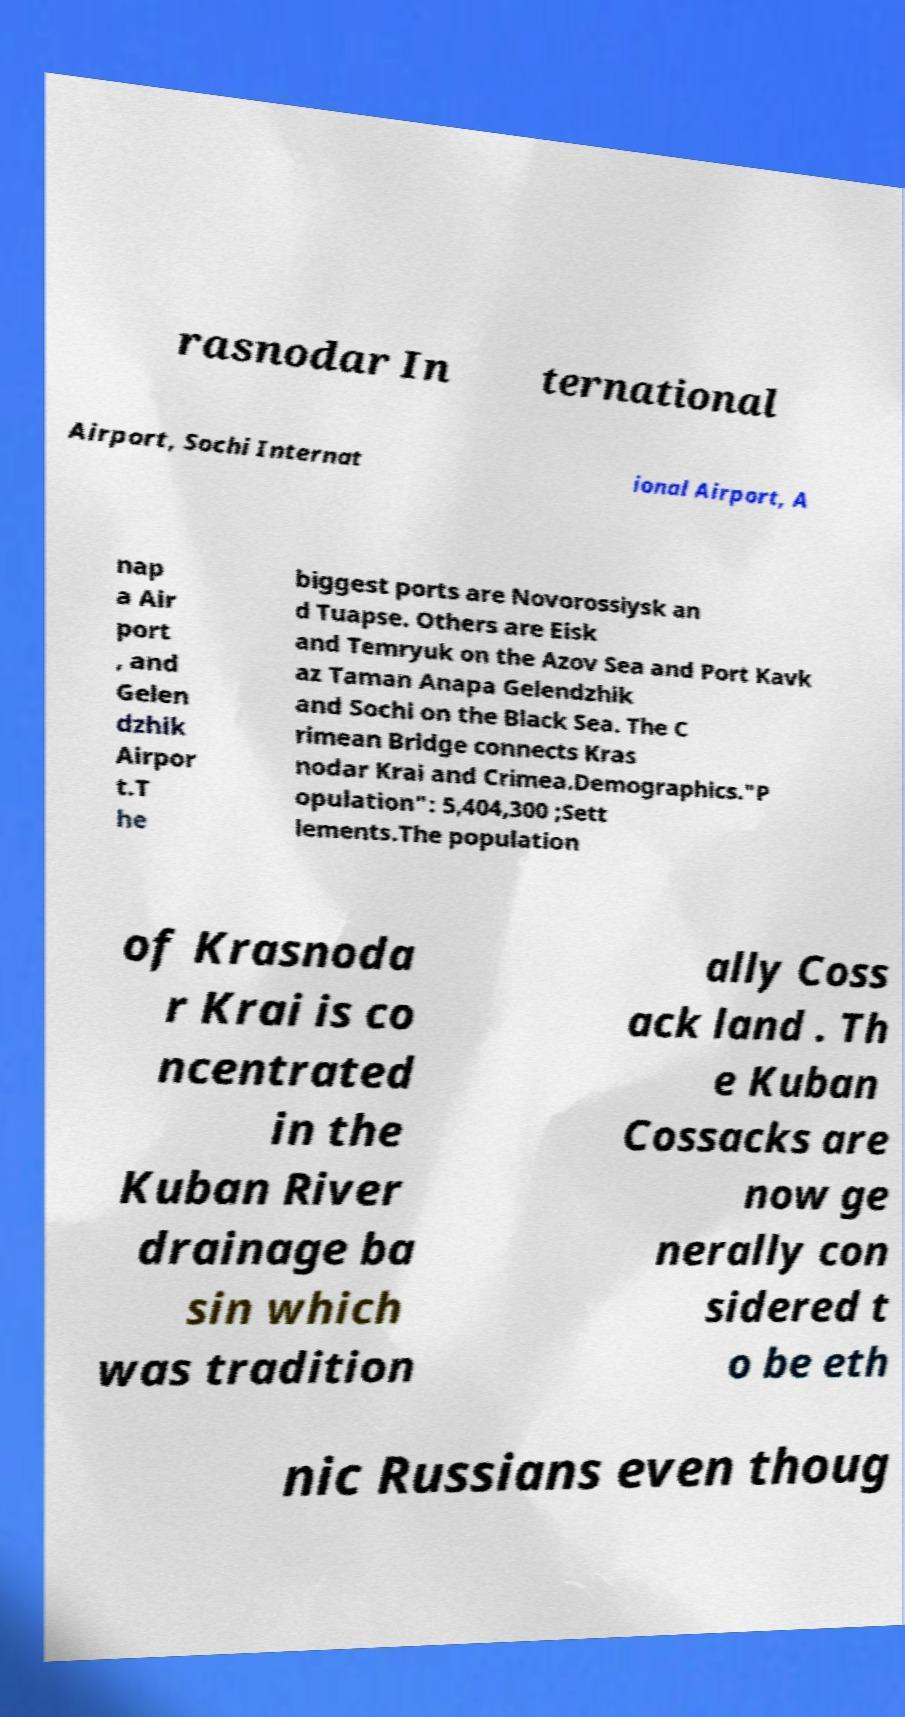Can you accurately transcribe the text from the provided image for me? rasnodar In ternational Airport, Sochi Internat ional Airport, A nap a Air port , and Gelen dzhik Airpor t.T he biggest ports are Novorossiysk an d Tuapse. Others are Eisk and Temryuk on the Azov Sea and Port Kavk az Taman Anapa Gelendzhik and Sochi on the Black Sea. The C rimean Bridge connects Kras nodar Krai and Crimea.Demographics."P opulation": 5,404,300 ;Sett lements.The population of Krasnoda r Krai is co ncentrated in the Kuban River drainage ba sin which was tradition ally Coss ack land . Th e Kuban Cossacks are now ge nerally con sidered t o be eth nic Russians even thoug 